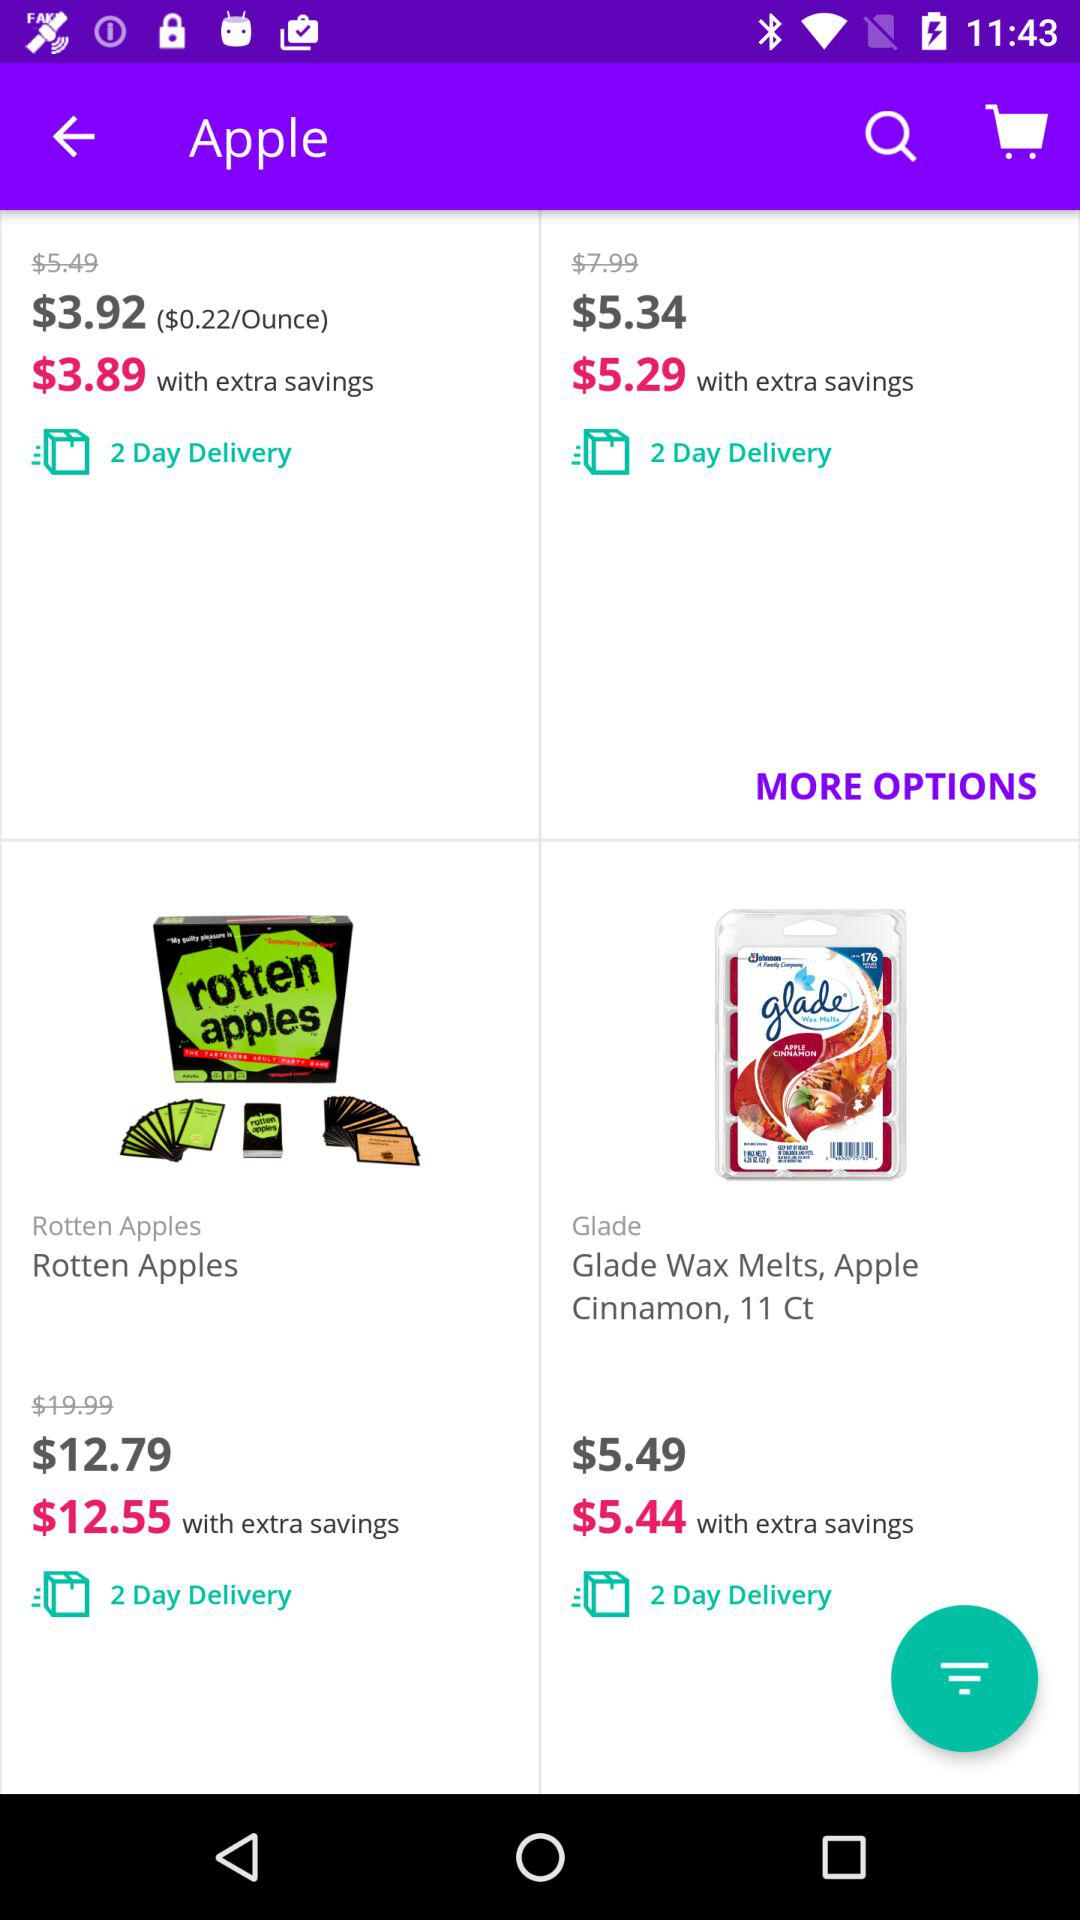What is the cost of "Rotten Apples"? The cost is $12.79. 